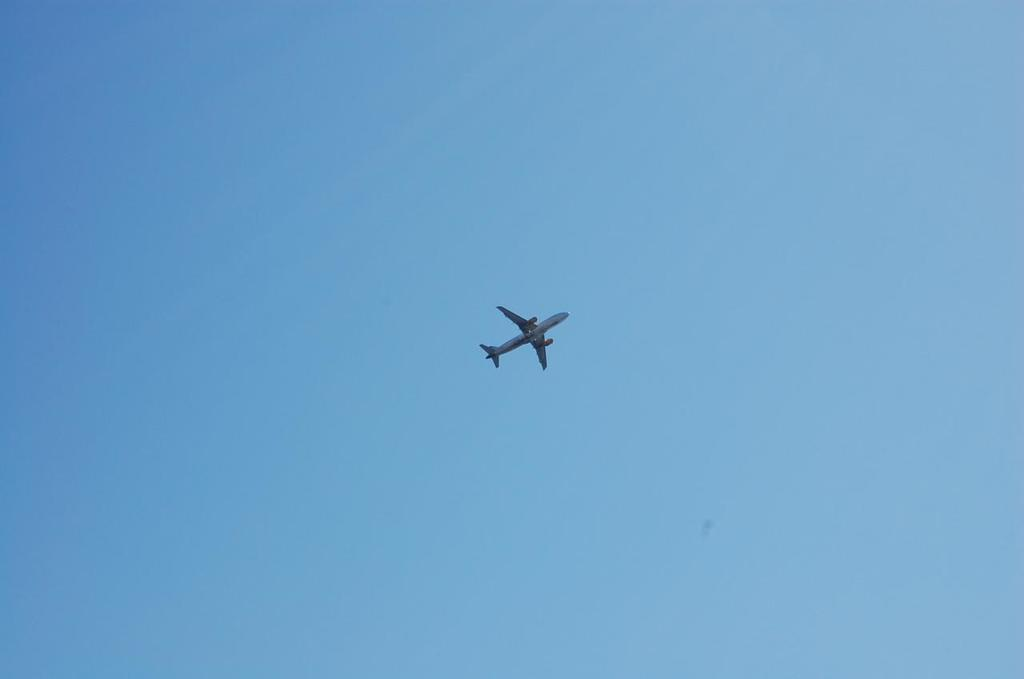What is the main subject of the image? The main subject of the image is an airplane. What is the airplane doing in the image? The airplane is flying in the air. What can be seen in the background of the image? There are clouds in the background of the image. What is the color of the sky in the image? The sky is blue in the image. What type of fruit is being offered to the passengers on the airplane in the image? There is no fruit or passengers present in the image; it only shows an airplane flying in the air. 